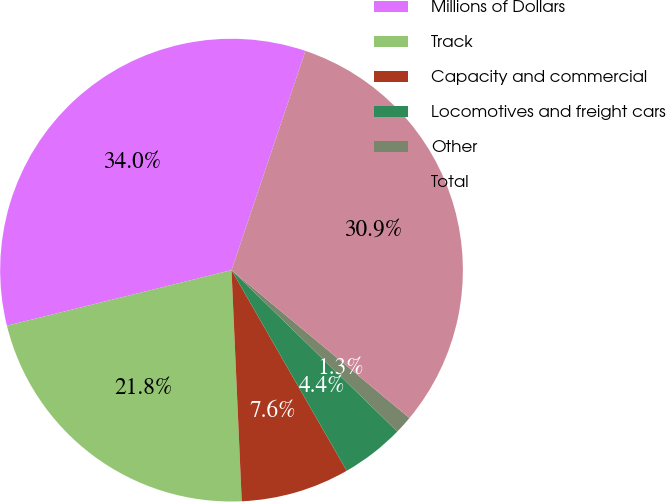Convert chart. <chart><loc_0><loc_0><loc_500><loc_500><pie_chart><fcel>Millions of Dollars<fcel>Track<fcel>Capacity and commercial<fcel>Locomotives and freight cars<fcel>Other<fcel>Total<nl><fcel>34.03%<fcel>21.84%<fcel>7.59%<fcel>4.42%<fcel>1.25%<fcel>30.86%<nl></chart> 